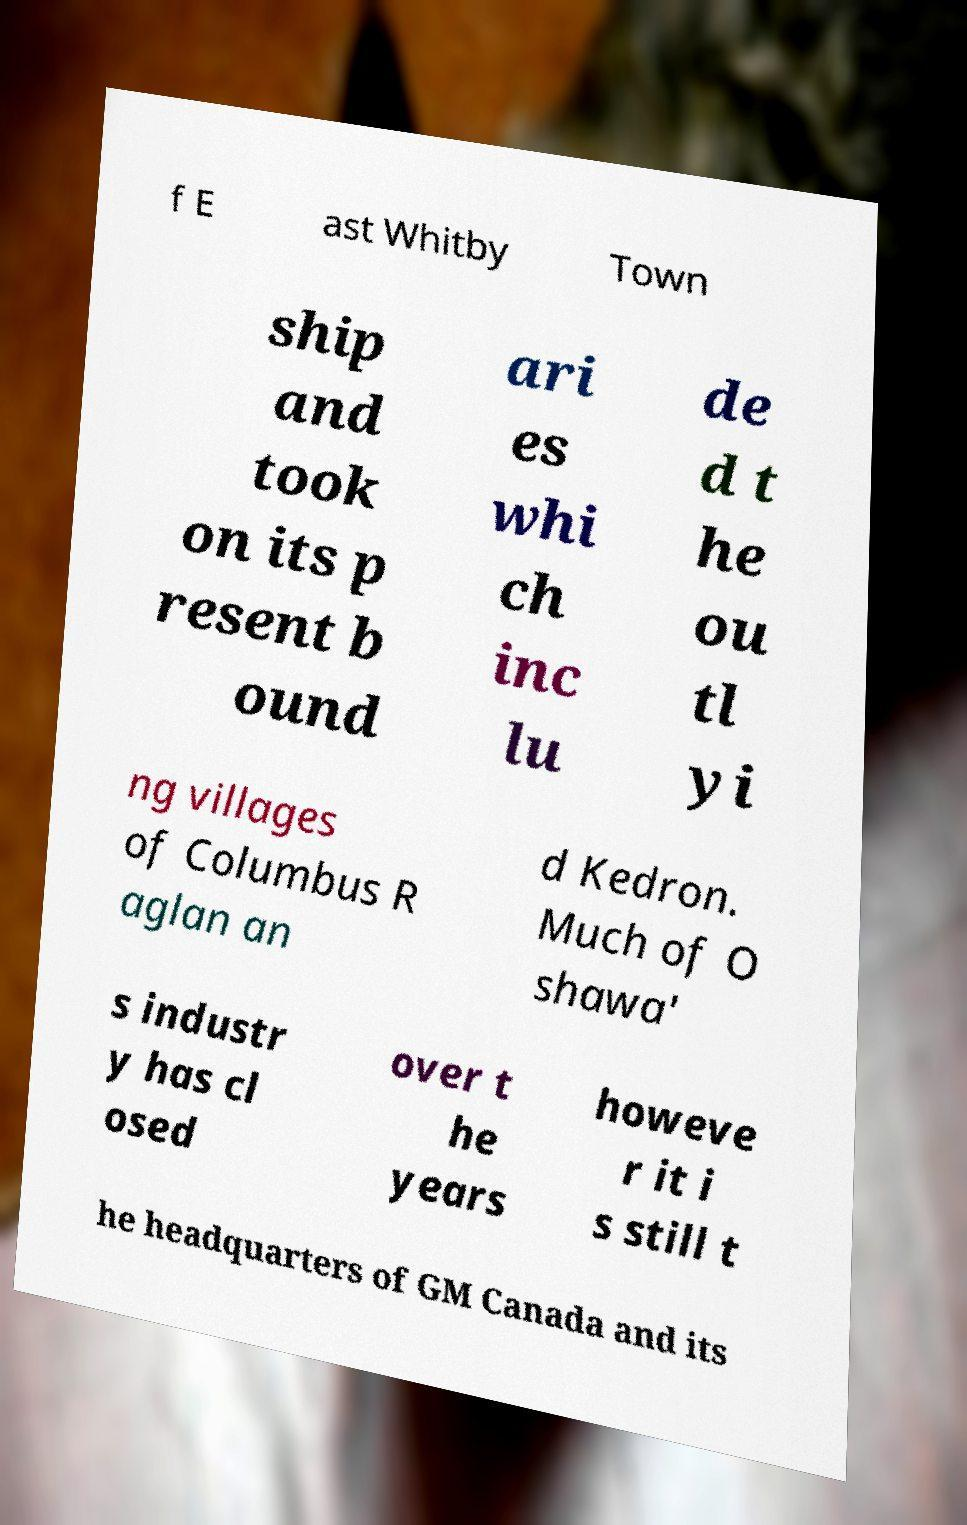Could you extract and type out the text from this image? f E ast Whitby Town ship and took on its p resent b ound ari es whi ch inc lu de d t he ou tl yi ng villages of Columbus R aglan an d Kedron. Much of O shawa' s industr y has cl osed over t he years howeve r it i s still t he headquarters of GM Canada and its 